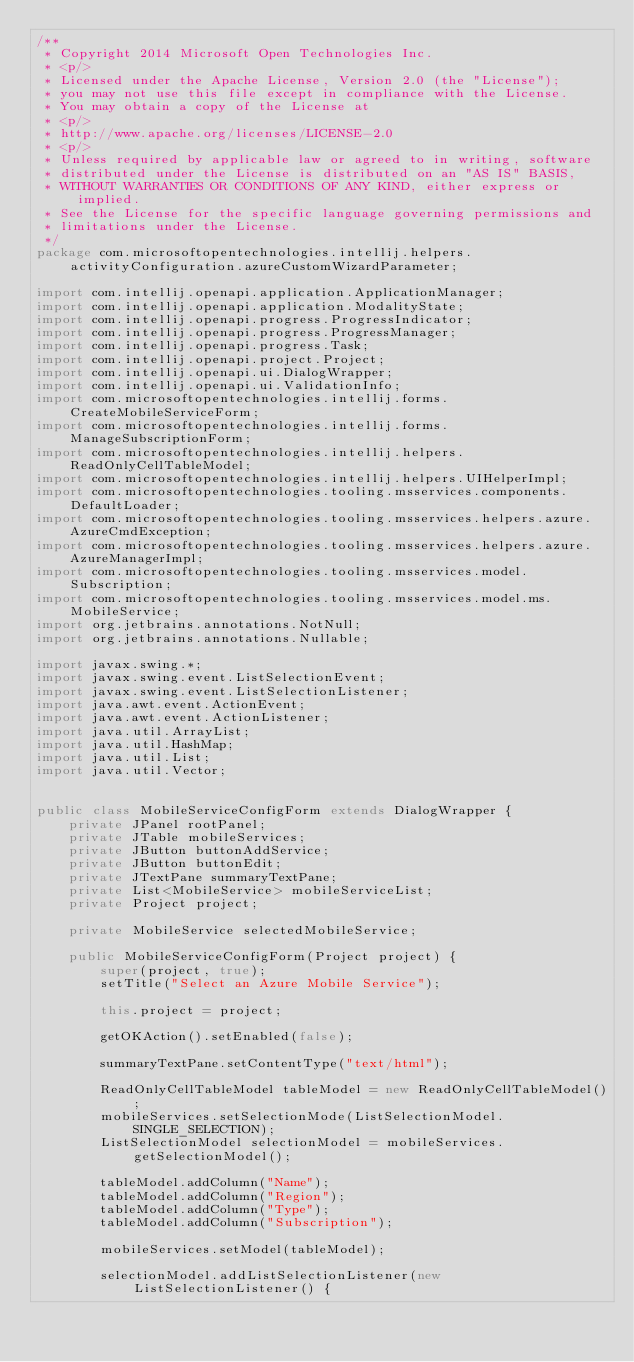<code> <loc_0><loc_0><loc_500><loc_500><_Java_>/**
 * Copyright 2014 Microsoft Open Technologies Inc.
 * <p/>
 * Licensed under the Apache License, Version 2.0 (the "License");
 * you may not use this file except in compliance with the License.
 * You may obtain a copy of the License at
 * <p/>
 * http://www.apache.org/licenses/LICENSE-2.0
 * <p/>
 * Unless required by applicable law or agreed to in writing, software
 * distributed under the License is distributed on an "AS IS" BASIS,
 * WITHOUT WARRANTIES OR CONDITIONS OF ANY KIND, either express or implied.
 * See the License for the specific language governing permissions and
 * limitations under the License.
 */
package com.microsoftopentechnologies.intellij.helpers.activityConfiguration.azureCustomWizardParameter;

import com.intellij.openapi.application.ApplicationManager;
import com.intellij.openapi.application.ModalityState;
import com.intellij.openapi.progress.ProgressIndicator;
import com.intellij.openapi.progress.ProgressManager;
import com.intellij.openapi.progress.Task;
import com.intellij.openapi.project.Project;
import com.intellij.openapi.ui.DialogWrapper;
import com.intellij.openapi.ui.ValidationInfo;
import com.microsoftopentechnologies.intellij.forms.CreateMobileServiceForm;
import com.microsoftopentechnologies.intellij.forms.ManageSubscriptionForm;
import com.microsoftopentechnologies.intellij.helpers.ReadOnlyCellTableModel;
import com.microsoftopentechnologies.intellij.helpers.UIHelperImpl;
import com.microsoftopentechnologies.tooling.msservices.components.DefaultLoader;
import com.microsoftopentechnologies.tooling.msservices.helpers.azure.AzureCmdException;
import com.microsoftopentechnologies.tooling.msservices.helpers.azure.AzureManagerImpl;
import com.microsoftopentechnologies.tooling.msservices.model.Subscription;
import com.microsoftopentechnologies.tooling.msservices.model.ms.MobileService;
import org.jetbrains.annotations.NotNull;
import org.jetbrains.annotations.Nullable;

import javax.swing.*;
import javax.swing.event.ListSelectionEvent;
import javax.swing.event.ListSelectionListener;
import java.awt.event.ActionEvent;
import java.awt.event.ActionListener;
import java.util.ArrayList;
import java.util.HashMap;
import java.util.List;
import java.util.Vector;


public class MobileServiceConfigForm extends DialogWrapper {
    private JPanel rootPanel;
    private JTable mobileServices;
    private JButton buttonAddService;
    private JButton buttonEdit;
    private JTextPane summaryTextPane;
    private List<MobileService> mobileServiceList;
    private Project project;

    private MobileService selectedMobileService;

    public MobileServiceConfigForm(Project project) {
        super(project, true);
        setTitle("Select an Azure Mobile Service");

        this.project = project;

        getOKAction().setEnabled(false);

        summaryTextPane.setContentType("text/html");

        ReadOnlyCellTableModel tableModel = new ReadOnlyCellTableModel();
        mobileServices.setSelectionMode(ListSelectionModel.SINGLE_SELECTION);
        ListSelectionModel selectionModel = mobileServices.getSelectionModel();

        tableModel.addColumn("Name");
        tableModel.addColumn("Region");
        tableModel.addColumn("Type");
        tableModel.addColumn("Subscription");

        mobileServices.setModel(tableModel);

        selectionModel.addListSelectionListener(new ListSelectionListener() {</code> 